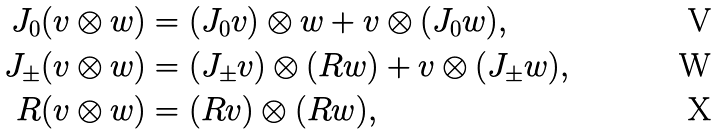<formula> <loc_0><loc_0><loc_500><loc_500>J _ { 0 } ( v \otimes w ) & = ( J _ { 0 } v ) \otimes w + v \otimes ( J _ { 0 } w ) , \\ J _ { \pm } ( v \otimes w ) & = ( J _ { \pm } v ) \otimes ( R w ) + v \otimes ( J _ { \pm } w ) , \\ R ( v \otimes w ) & = ( R v ) \otimes ( R w ) ,</formula> 